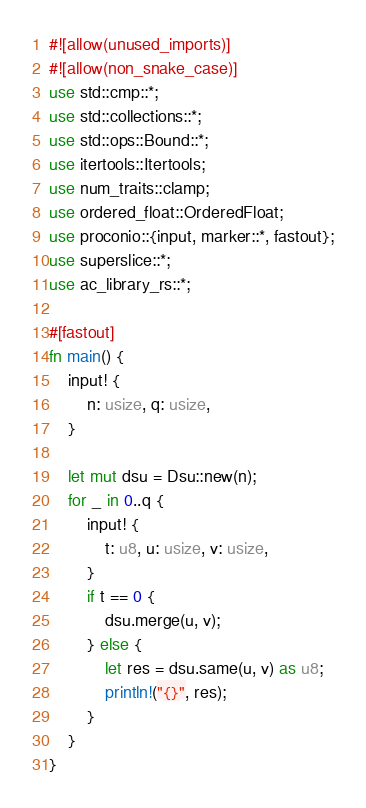<code> <loc_0><loc_0><loc_500><loc_500><_Rust_>#![allow(unused_imports)]
#![allow(non_snake_case)]
use std::cmp::*;
use std::collections::*;
use std::ops::Bound::*;
use itertools::Itertools;
use num_traits::clamp;
use ordered_float::OrderedFloat;
use proconio::{input, marker::*, fastout};
use superslice::*;
use ac_library_rs::*;

#[fastout]
fn main() {
    input! {
        n: usize, q: usize,
    }

    let mut dsu = Dsu::new(n);
    for _ in 0..q {
        input! {
            t: u8, u: usize, v: usize,
        }
        if t == 0 {
            dsu.merge(u, v);
        } else {
            let res = dsu.same(u, v) as u8;
            println!("{}", res);
        }
    }
}
</code> 